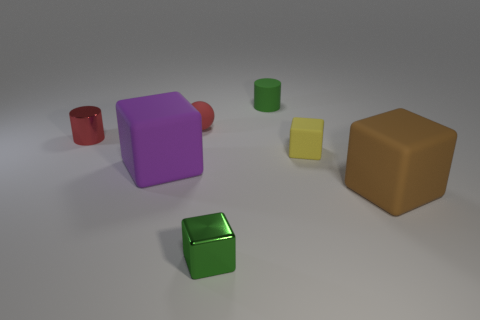Subtract all big brown rubber blocks. How many blocks are left? 3 Subtract all red cylinders. How many cylinders are left? 1 Subtract all balls. How many objects are left? 6 Add 2 small metallic cylinders. How many objects exist? 9 Subtract 0 gray cubes. How many objects are left? 7 Subtract 1 blocks. How many blocks are left? 3 Subtract all green spheres. Subtract all yellow cylinders. How many spheres are left? 1 Subtract all green cylinders. How many green spheres are left? 0 Subtract all big brown rubber objects. Subtract all large purple shiny cylinders. How many objects are left? 6 Add 4 purple blocks. How many purple blocks are left? 5 